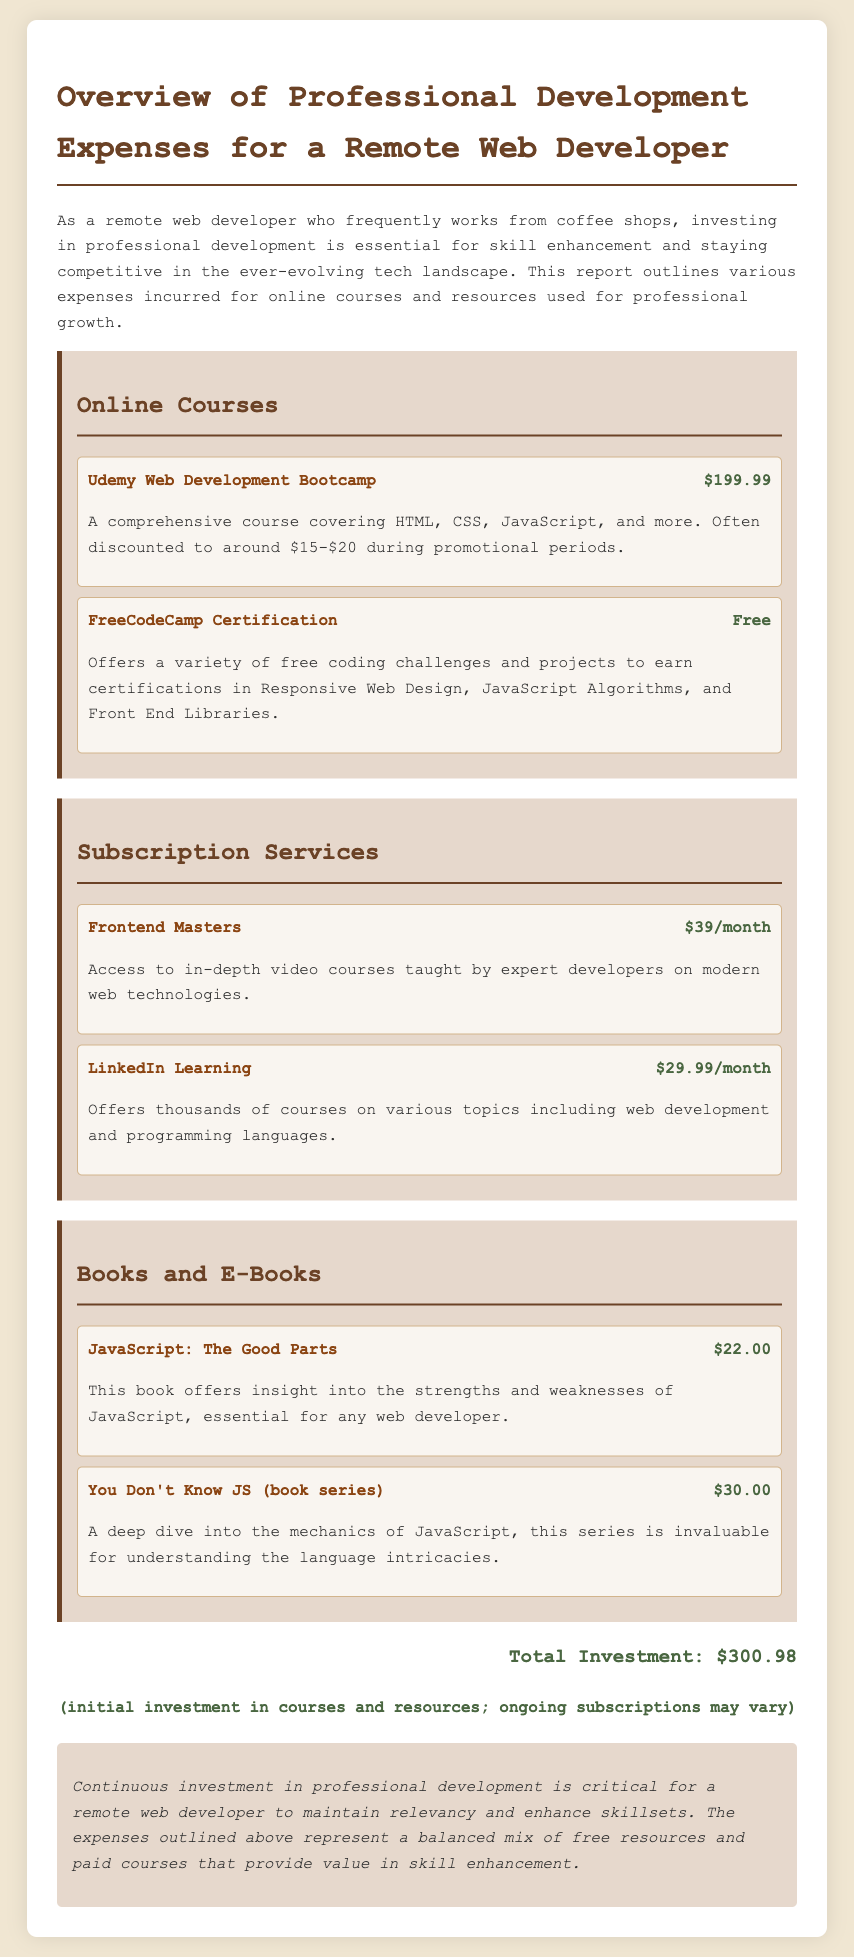what is the total investment? The total investment is the cumulative amount spent on all courses and resources outlined in the document, which sums to $300.98.
Answer: $300.98 how much does the Udemy Web Development Bootcamp cost? The document states the cost of the Udemy Web Development Bootcamp as $199.99.
Answer: $199.99 what is the monthly cost of Frontend Masters? Frontend Masters has a specified cost of $39 per month in the report.
Answer: $39/month which platform offers free coding challenges and projects? The document mentions FreeCodeCamp as a platform that offers free resources for coding challenges and projects.
Answer: FreeCodeCamp how much is the subscription for LinkedIn Learning? LinkedIn Learning is priced at $29.99 per month according to the report.
Answer: $29.99/month what is the title of a book that dives deep into JavaScript's mechanics? The report lists "You Don't Know JS (book series)" as the title that provides an in-depth view of JavaScript mechanics.
Answer: You Don't Know JS (book series) what type of resources does the report mainly discuss? The document outlines expenses related to professional development, specifically focusing on online courses and resources.
Answer: Online courses and resources what is the primary benefit of investing in professional development according to the document? The conclusion of the report highlights that the continuous investment in professional development maintains relevancy and enhances skillsets for remote web developers.
Answer: Maintain relevancy and enhance skillsets how many categories of expenses are presented in the report? The document has three distinct categories of expenses listed: Online Courses, Subscription Services, and Books and E-Books.
Answer: Three categories 